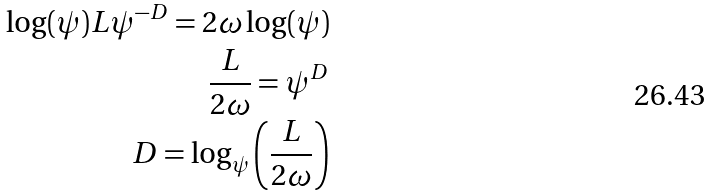<formula> <loc_0><loc_0><loc_500><loc_500>\log ( \psi ) L \psi ^ { - D } = 2 \omega \log ( \psi ) \\ \frac { L } { 2 \omega } = \psi ^ { D } \\ D = \log _ { \psi } \left ( \frac { L } { 2 \omega } \right )</formula> 